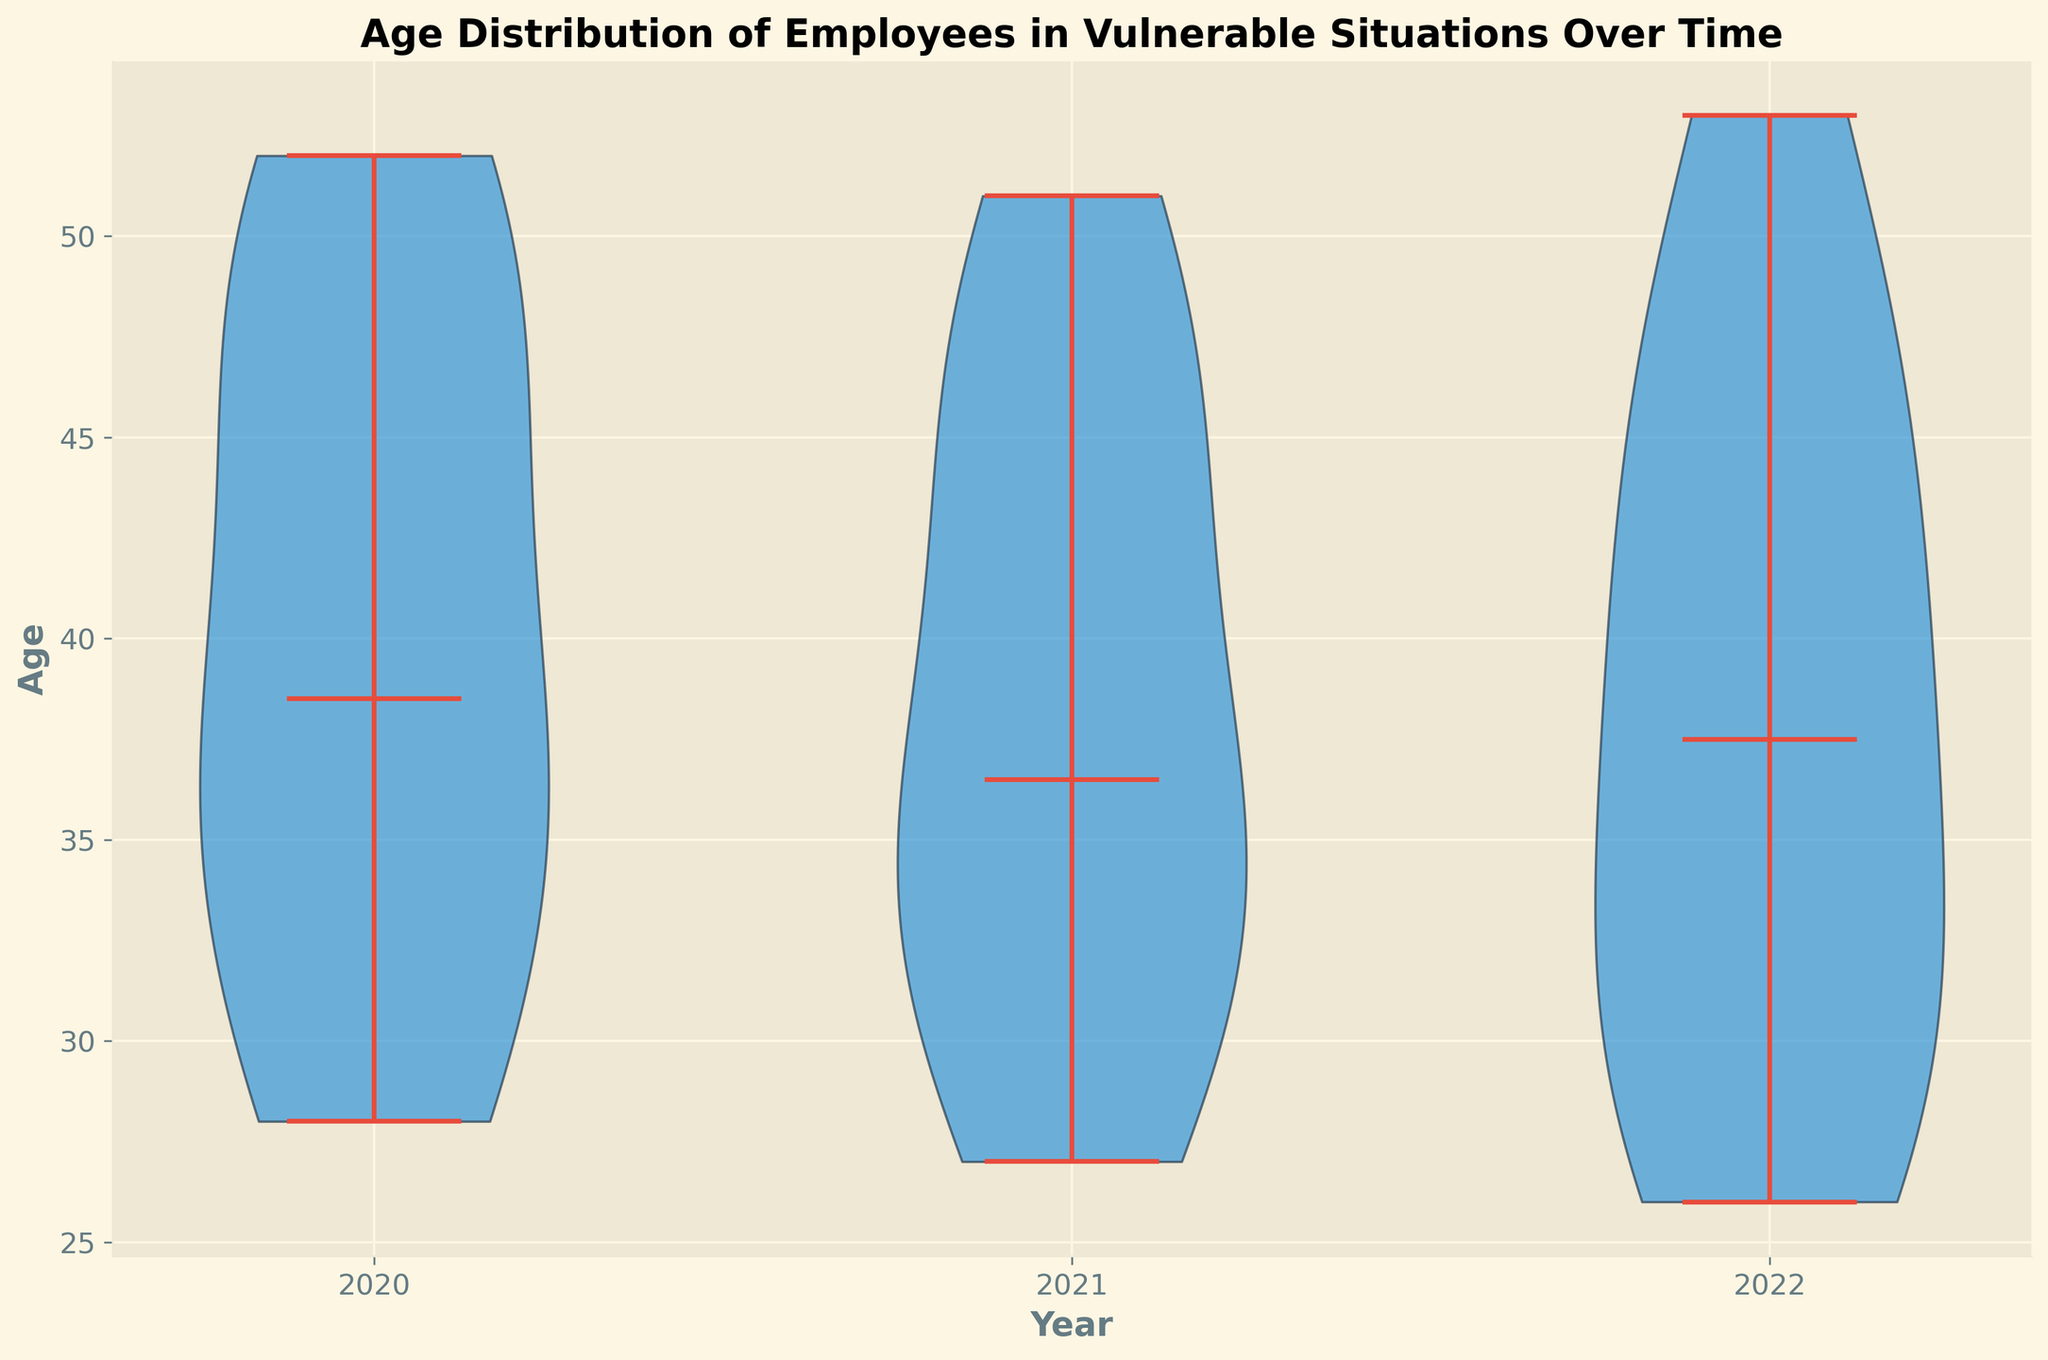What is the time range displayed in the figure? The x-axis shows the years that are included in the figure. The visible years range from 2020 to 2022.
Answer: 2020 to 2022 What's the median age of employees in the year 2022? The median age for each year is indicated by the horizontal lines within the violin plots. For 2022, this line corresponds to the median value. It appears around 36.
Answer: 36 How does the age distribution change from 2020 to 2022? In a violin plot, the distribution's width at different ages shows the density. From 2020 to 2022, the distributions seem to shift slightly younger but remain quite similar, indicating a consistent age range.
Answer: Slightly younger but consistent Which year has the greatest spread in the age of employees? Spread in age can be inferred by looking at the vertical range of each violin plot. The year with the widest spread appears to be 2022, where ages range more widely from mid-20s to early 50s.
Answer: 2022 In which year do we see the youngest employee? The lowest point of the violin plot for each year represents the youngest age. In 2022, there is a data point at around age 26, which is the youngest compared to other years.
Answer: 2022 Which year has the highest median age of employees? The horizontal lines within each violin plot represent the medians. In 2021, the median appears to be the highest among the three years observed.
Answer: 2021 How does the age distribution for the year 2020 compare to 2021? By comparing the shapes and ranges of the 2020 and 2021 violin plots, one can see both distributions have a central bulk between around late 20s to early 50s, but 2021 shows a slightly older median and similar spread.
Answer: Slightly older median in 2021, similar spread What is the most common age range for employees in 2020? The widest part of the violin plot for 2020 indicates the most common age range, which appears to be between 34 and 45 years.
Answer: 34 to 45 years How does the peak density of employee ages shift from 2020 to 2022? The peak density is shown where the violin plot is the widest. In 2020, it is around the mid-40s, while in 2022, it appears to shift slightly younger, more around mid-30s.
Answer: From mid-40s to mid-30s Is there a year where the employee age distribution is skewed more towards the younger or older side? The shape of the violin plot shows skewness. 2021 appears slightly skewed towards older ages, whereas 2020 and 2022 look more symmetrically distributed.
Answer: 2021 more towards older 